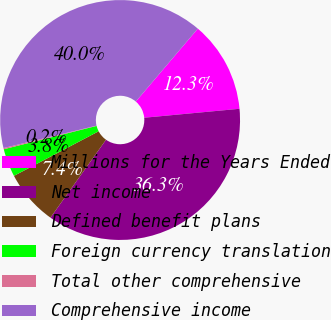Convert chart to OTSL. <chart><loc_0><loc_0><loc_500><loc_500><pie_chart><fcel>Millions for the Years Ended<fcel>Net income<fcel>Defined benefit plans<fcel>Foreign currency translation<fcel>Total other comprehensive<fcel>Comprehensive income<nl><fcel>12.29%<fcel>36.35%<fcel>7.43%<fcel>3.79%<fcel>0.16%<fcel>39.98%<nl></chart> 